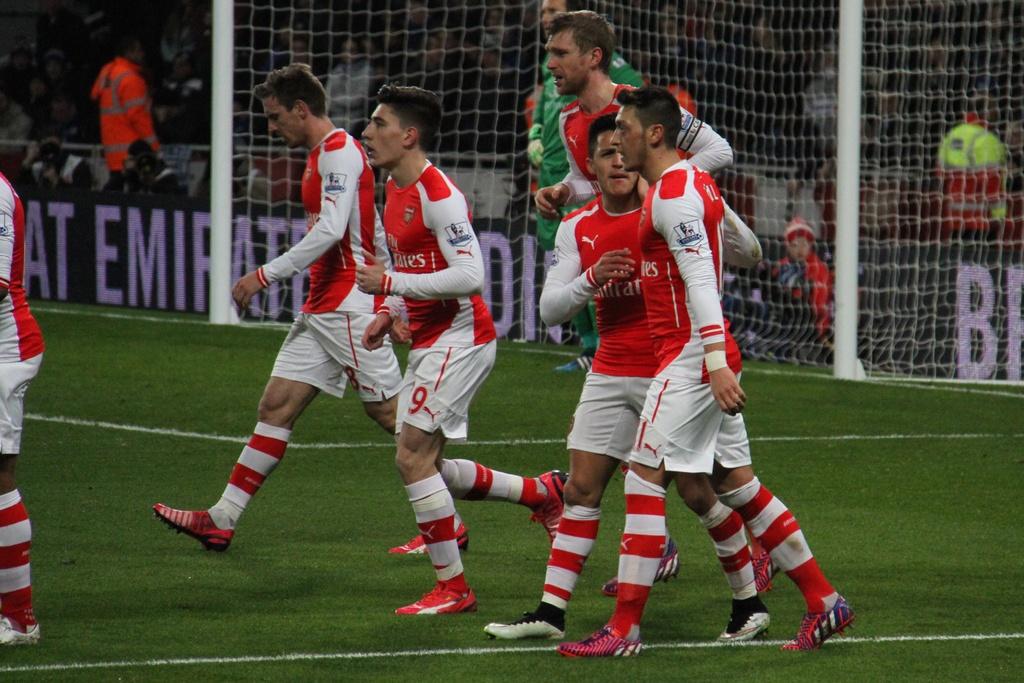What number is visible on the mans shorts in the center?
Provide a short and direct response. 9. What letters can you see behind the men?
Give a very brief answer. At emirat di b. 